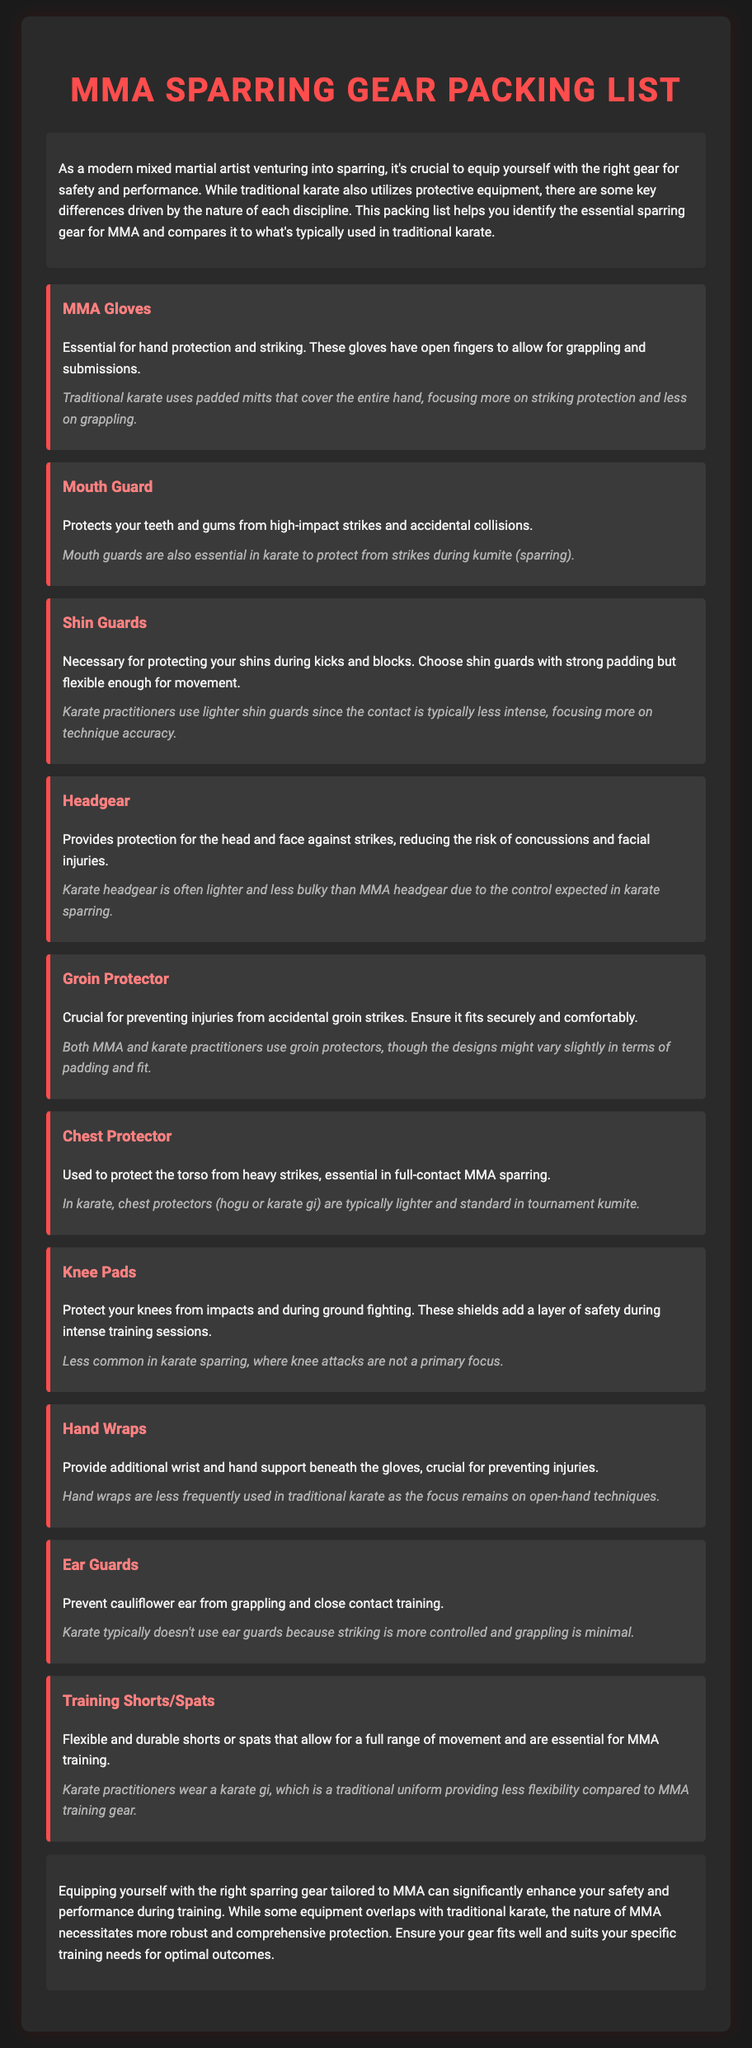What is the primary function of MMA gloves? MMA gloves provide essential hand protection and striking, with open fingers for grappling and submissions.
Answer: Hand protection and striking What do shin guards protect against? Shin guards are necessary for protecting your shins during kicks and blocks.
Answer: Shins during kicks and blocks How does traditional karate headgear differ from MMA headgear? Traditional karate headgear is often lighter and less bulky than MMA headgear due to the control expected in karate sparring.
Answer: Lighter and less bulky What type of protector is used both in MMA and karate? Both MMA and karate practitioners use groin protectors, though the designs might vary slightly in terms of padding and fit.
Answer: Groin protector Which sparring gear is specific to MMA and not commonly used in karate? Knee pads are less common in karate sparring, where knee attacks are not a primary focus.
Answer: Knee pads What is the purpose of a mouth guard in both disciplines? The mouth guard protects teeth and gums from high-impact strikes and accidental collisions.
Answer: Protects teeth and gums What type of clothing do MMA fighters typically wear during training? MMA fighters typically wear flexible and durable training shorts or spats.
Answer: Training shorts or spats What do hand wraps provide for MMA fighters? Hand wraps provide additional wrist and hand support beneath the gloves.
Answer: Wrist and hand support What are training shorts designed for in MMA? Training shorts are designed to allow for a full range of movement and are essential for MMA training.
Answer: Full range of movement 